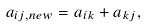<formula> <loc_0><loc_0><loc_500><loc_500>a _ { i j , n e w } = a _ { i k } + a _ { k j } ,</formula> 